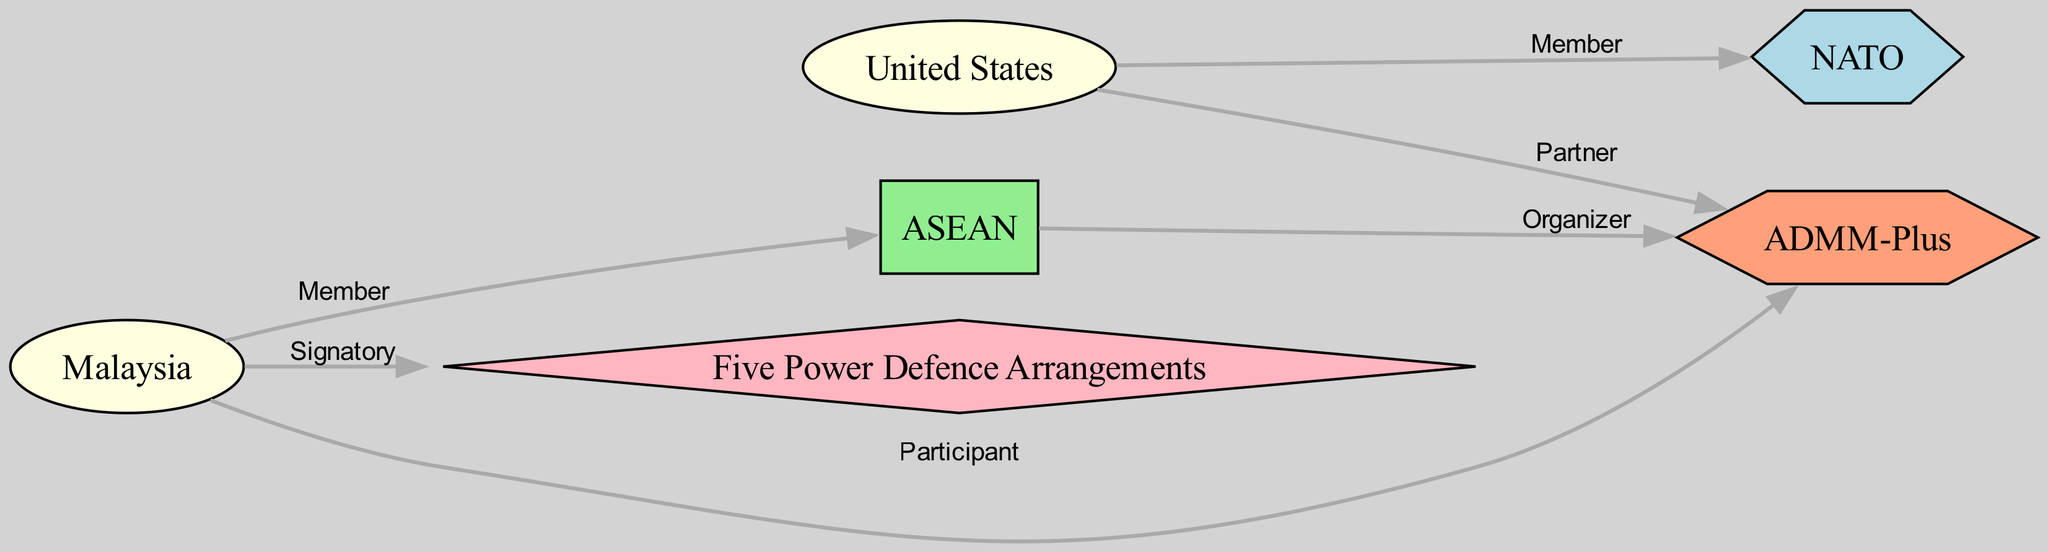What is the total number of nodes in the diagram? The diagram contains six distinct nodes: NATO, ASEAN, Malaysia, United States, Five Power Defence Arrangements, and ADMM-Plus. Counting these nodes gives a total of six.
Answer: 6 Which country is a member of NATO? The edge labeled "Member" connects the United States as a source node to NATO as a target node, indicating that the United States is a member of NATO.
Answer: United States What type of agreement is the Five Power Defence Arrangements? The diagram classifies the Five Power Defence Arrangements as an "Agreement," which is indicated by the node type assigned to it.
Answer: Agreement How many edges are related to Malaysia? Malaysia has three edges: one indicating "Member" relationship with ASEAN, one indicating "Signatory" relationship with Five Power Defence Arrangements, and one indicating "Participant" role in ADMM-Plus. Counting these, we find out there are three edges.
Answer: 3 Which organizations does the United States cooperate with? The diagram shows two edges from the United States: one indicating "Member" relationship with NATO and one indicating "Partner" relationship with ADMM-Plus, indicating both NATO and ADMM-Plus as organizations it cooperates with.
Answer: NATO, ADMM-Plus What role does ASEAN play in ADMM-Plus? The edge between ASEAN and ADMM-Plus is labeled "Organizer," suggesting that ASEAN has a role in organizing the ADMM-Plus forum.
Answer: Organizer Who are the participants in the Five Power Defence Arrangements? The diagram has only one edge connecting Malaysia as the "Signatory" to the Five Power Defence Arrangements, indicating that Malaysia is part of this arrangement.
Answer: Malaysia How many regional organizations are present? The diagram includes ASEAN as the only regional organization node; hence, the count is one.
Answer: 1 Which node labels connect the United States and Malaysia? The diagram displays edges connecting both nodes indirectly. The United States connects to NATO and ADMM-Plus, while Malaysia connects to ASEAN, Five Power Defence Arrangements, and ADMM-Plus. The common node linking them indirectly is ADMM-Plus, but there is no direct connection with a specific label between them.
Answer: ADMM-Plus 